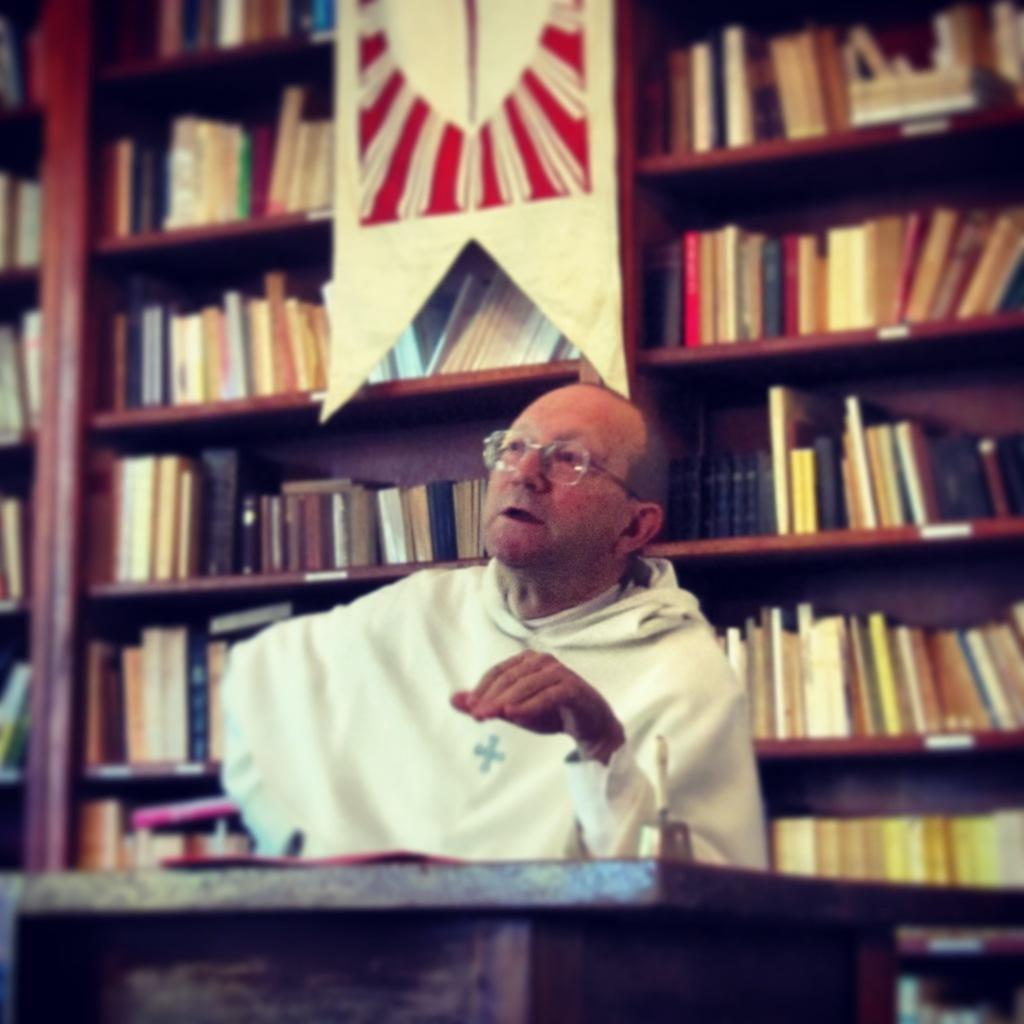Please provide a concise description of this image. In this picture I can see a man sitting, there is a bell on the table, and in the background there are books arranged in an order in the racks, and this is looking like a fabric banner. 